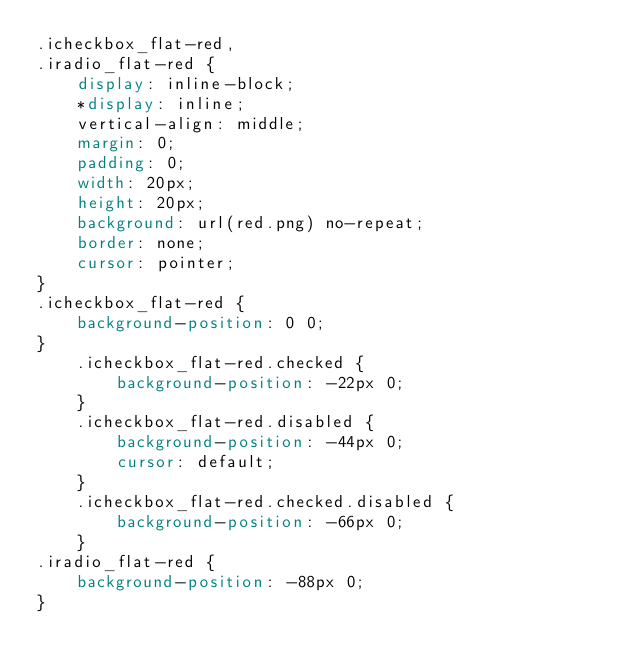Convert code to text. <code><loc_0><loc_0><loc_500><loc_500><_CSS_>.icheckbox_flat-red,
.iradio_flat-red {
    display: inline-block;
    *display: inline;
    vertical-align: middle;
    margin: 0;
    padding: 0;
    width: 20px;
    height: 20px;
    background: url(red.png) no-repeat;
    border: none;
    cursor: pointer;
}
.icheckbox_flat-red {
    background-position: 0 0;
}
    .icheckbox_flat-red.checked {
        background-position: -22px 0;
    }
    .icheckbox_flat-red.disabled {
        background-position: -44px 0;
        cursor: default;
    }
    .icheckbox_flat-red.checked.disabled {
        background-position: -66px 0;
    }
.iradio_flat-red {
    background-position: -88px 0;
}</code> 